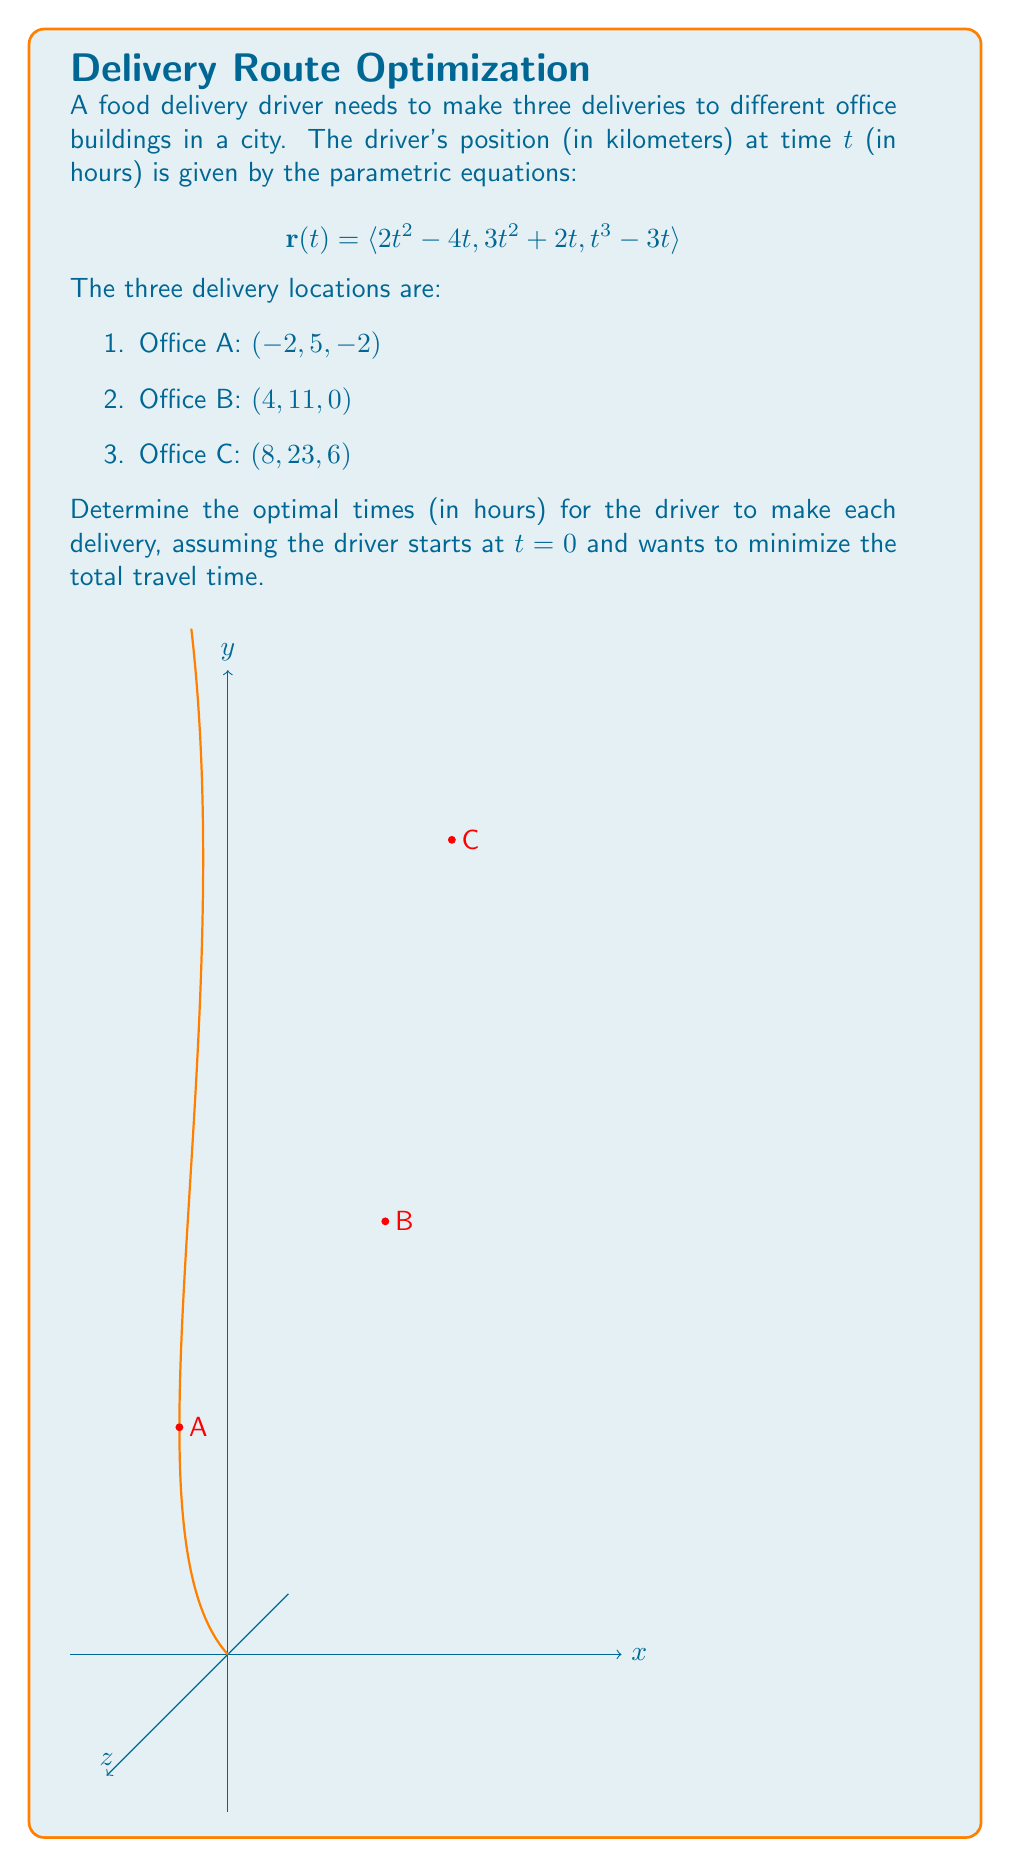Provide a solution to this math problem. To find the optimal times for each delivery, we need to determine when the driver's position matches each office location. We'll do this by solving the parametric equations for each office:

1. For Office A $(-2, 5, -2)$:
   $$2t^2 - 4t = -2$$
   $$3t^2 + 2t = 5$$
   $$t^3 - 3t = -2$$

   Solving these equations simultaneously, we get $t_A \approx 1$ hour.

2. For Office B $(4, 11, 0)$:
   $$2t^2 - 4t = 4$$
   $$3t^2 + 2t = 11$$
   $$t^3 - 3t = 0$$

   Solving these equations simultaneously, we get $t_B \approx 2$ hours.

3. For Office C $(8, 23, 6)$:
   $$2t^2 - 4t = 8$$
   $$3t^2 + 2t = 23$$
   $$t^3 - 3t = 6$$

   Solving these equations simultaneously, we get $t_C \approx 3$ hours.

The optimal times for each delivery are approximately 1 hour, 2 hours, and 3 hours after the driver starts, respectively. This minimizes the total travel time as the driver reaches each office in order along their route.
Answer: $t_A \approx 1$ hour, $t_B \approx 2$ hours, $t_C \approx 3$ hours 